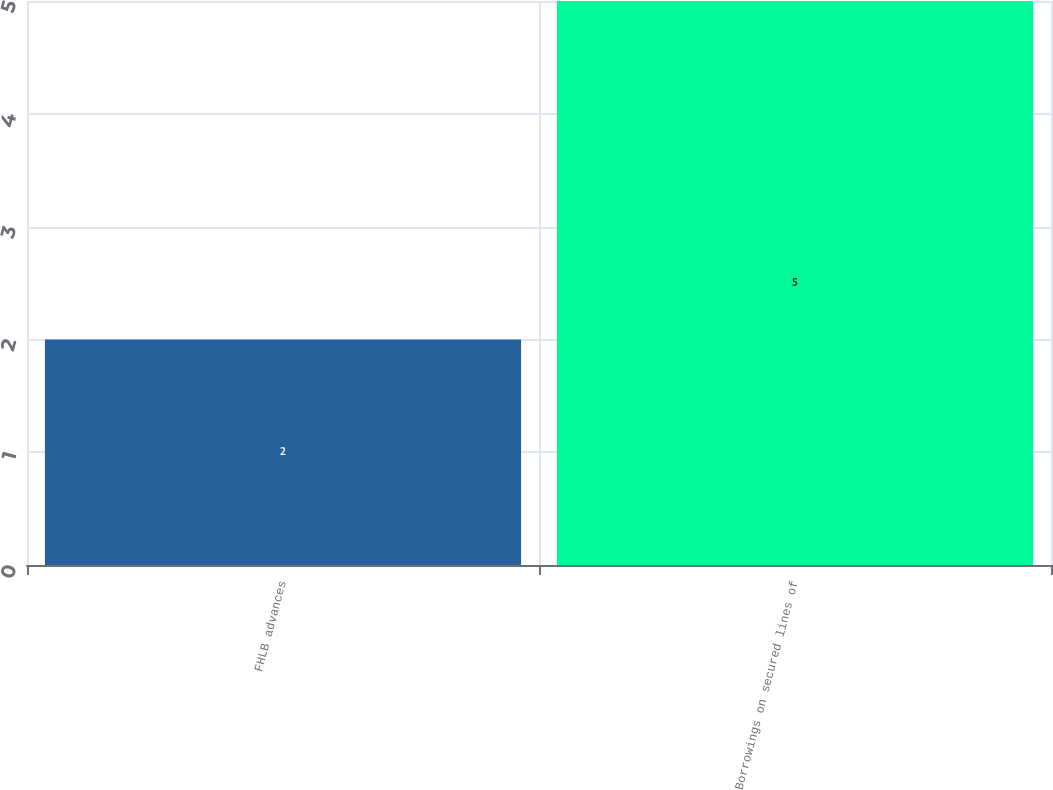Convert chart. <chart><loc_0><loc_0><loc_500><loc_500><bar_chart><fcel>FHLB advances<fcel>Borrowings on secured lines of<nl><fcel>2<fcel>5<nl></chart> 